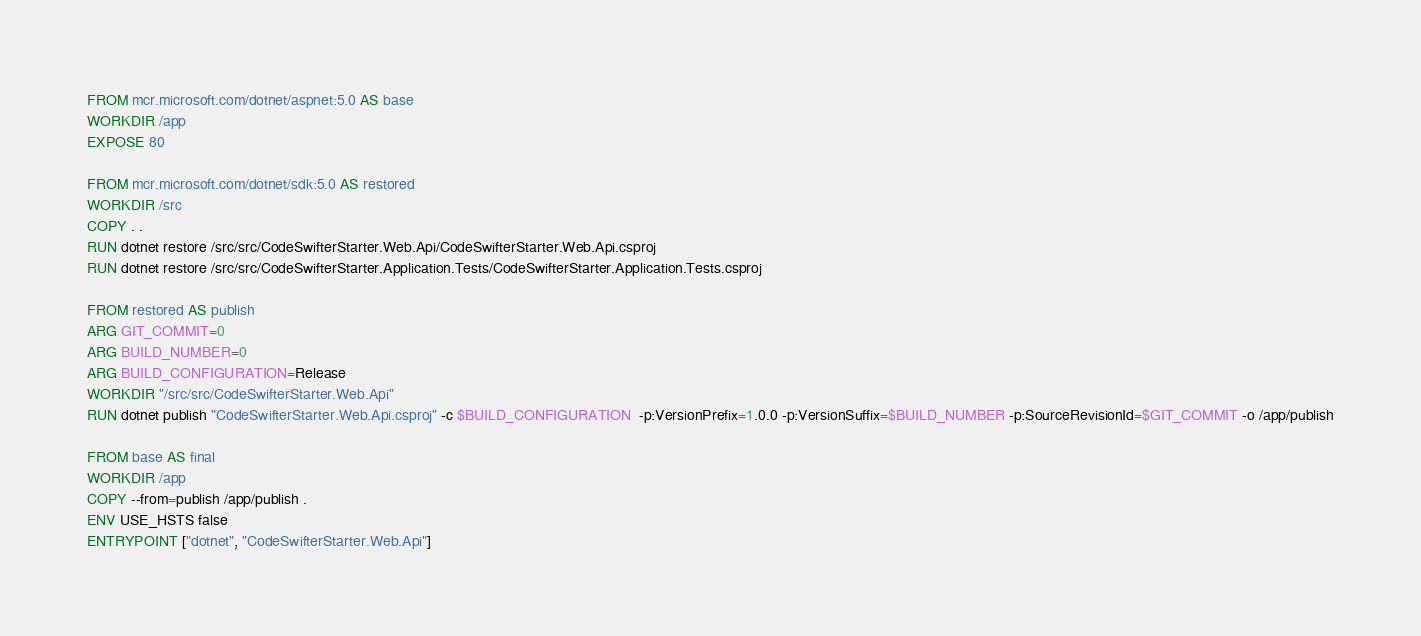Convert code to text. <code><loc_0><loc_0><loc_500><loc_500><_Dockerfile_>FROM mcr.microsoft.com/dotnet/aspnet:5.0 AS base
WORKDIR /app
EXPOSE 80

FROM mcr.microsoft.com/dotnet/sdk:5.0 AS restored
WORKDIR /src
COPY . .
RUN dotnet restore /src/src/CodeSwifterStarter.Web.Api/CodeSwifterStarter.Web.Api.csproj
RUN dotnet restore /src/src/CodeSwifterStarter.Application.Tests/CodeSwifterStarter.Application.Tests.csproj

FROM restored AS publish
ARG GIT_COMMIT=0
ARG BUILD_NUMBER=0
ARG BUILD_CONFIGURATION=Release
WORKDIR "/src/src/CodeSwifterStarter.Web.Api"
RUN dotnet publish "CodeSwifterStarter.Web.Api.csproj" -c $BUILD_CONFIGURATION  -p:VersionPrefix=1.0.0 -p:VersionSuffix=$BUILD_NUMBER -p:SourceRevisionId=$GIT_COMMIT -o /app/publish

FROM base AS final
WORKDIR /app
COPY --from=publish /app/publish .
ENV USE_HSTS false
ENTRYPOINT ["dotnet", "CodeSwifterStarter.Web.Api"]</code> 